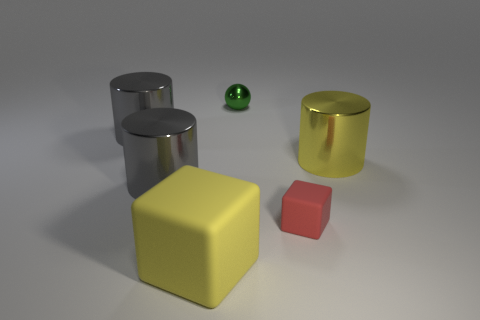Subtract all big yellow metal cylinders. How many cylinders are left? 2 Subtract all gray balls. How many gray cylinders are left? 2 Add 1 red cylinders. How many objects exist? 7 Subtract all gray cylinders. How many cylinders are left? 1 Subtract all cubes. How many objects are left? 4 Add 2 tiny green things. How many tiny green things are left? 3 Add 5 yellow shiny cylinders. How many yellow shiny cylinders exist? 6 Subtract 0 green cylinders. How many objects are left? 6 Subtract all cyan blocks. Subtract all yellow cylinders. How many blocks are left? 2 Subtract all blue shiny blocks. Subtract all large metal things. How many objects are left? 3 